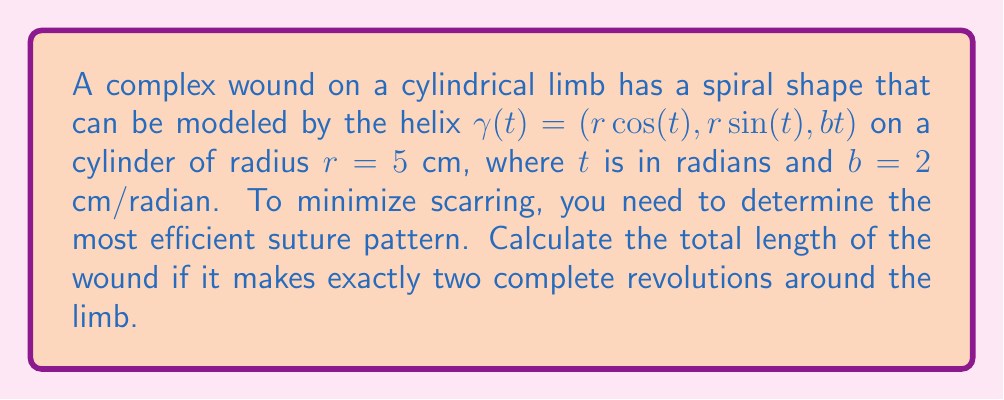What is the answer to this math problem? To solve this problem, we'll follow these steps:

1) The helix is given by $\gamma(t) = (r\cos(t), r\sin(t), bt)$ where $r=5$ cm and $b=2$ cm/radian.

2) To find the length of the curve, we need to calculate the arc length integral:

   $$L = \int_a^b \sqrt{\left(\frac{dx}{dt}\right)^2 + \left(\frac{dy}{dt}\right)^2 + \left(\frac{dz}{dt}\right)^2} dt$$

3) Let's calculate the derivatives:
   $$\frac{dx}{dt} = -r\sin(t)$$
   $$\frac{dy}{dt} = r\cos(t)$$
   $$\frac{dz}{dt} = b$$

4) Substituting these into the integral:

   $$L = \int_a^b \sqrt{(r\sin(t))^2 + (r\cos(t))^2 + b^2} dt$$

5) Simplify:
   $$L = \int_a^b \sqrt{r^2(\sin^2(t) + \cos^2(t)) + b^2} dt$$
   $$L = \int_a^b \sqrt{r^2 + b^2} dt$$

6) The term under the square root is constant, so we can take it out:
   $$L = \sqrt{r^2 + b^2} \int_a^b dt$$

7) Two complete revolutions mean $t$ goes from 0 to $4\pi$. So our integral becomes:
   $$L = \sqrt{r^2 + b^2} [t]_0^{4\pi} = 4\pi\sqrt{r^2 + b^2}$$

8) Substitute the values $r=5$ and $b=2$:
   $$L = 4\pi\sqrt{5^2 + 2^2} = 4\pi\sqrt{29} \approx 67.54\text{ cm}$$
Answer: $4\pi\sqrt{29} \approx 67.54\text{ cm}$ 